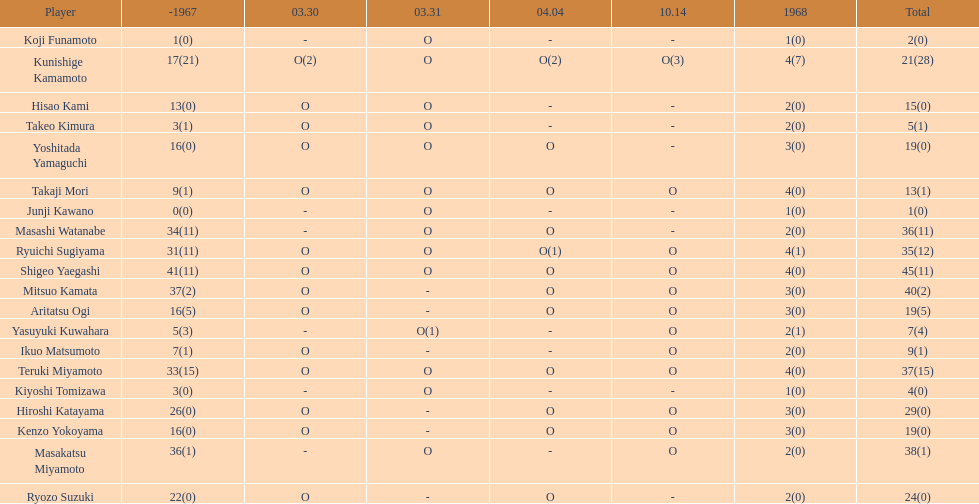Who had more points takaji mori or junji kawano? Takaji Mori. 